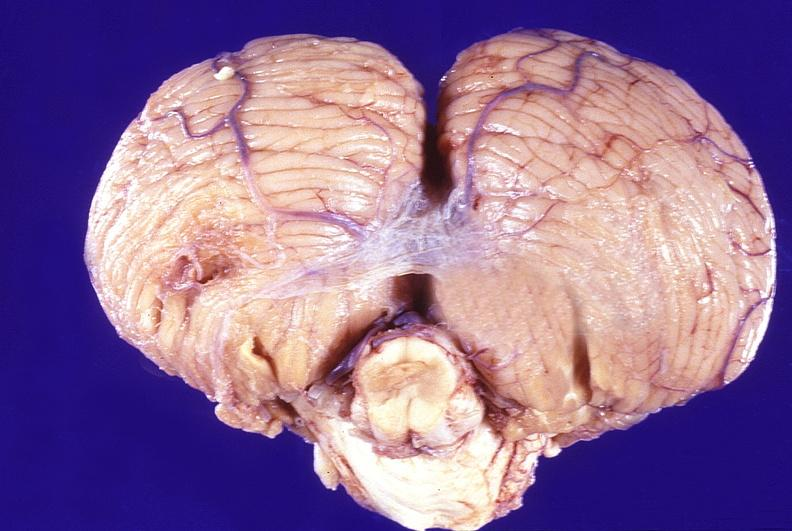s nervous present?
Answer the question using a single word or phrase. Yes 